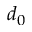Convert formula to latex. <formula><loc_0><loc_0><loc_500><loc_500>d _ { 0 }</formula> 